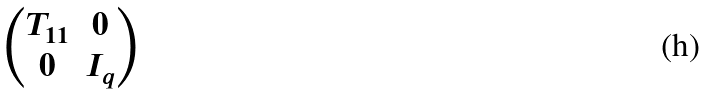Convert formula to latex. <formula><loc_0><loc_0><loc_500><loc_500>\begin{pmatrix} T _ { 1 1 } & 0 \\ 0 & I _ { q } \end{pmatrix}</formula> 